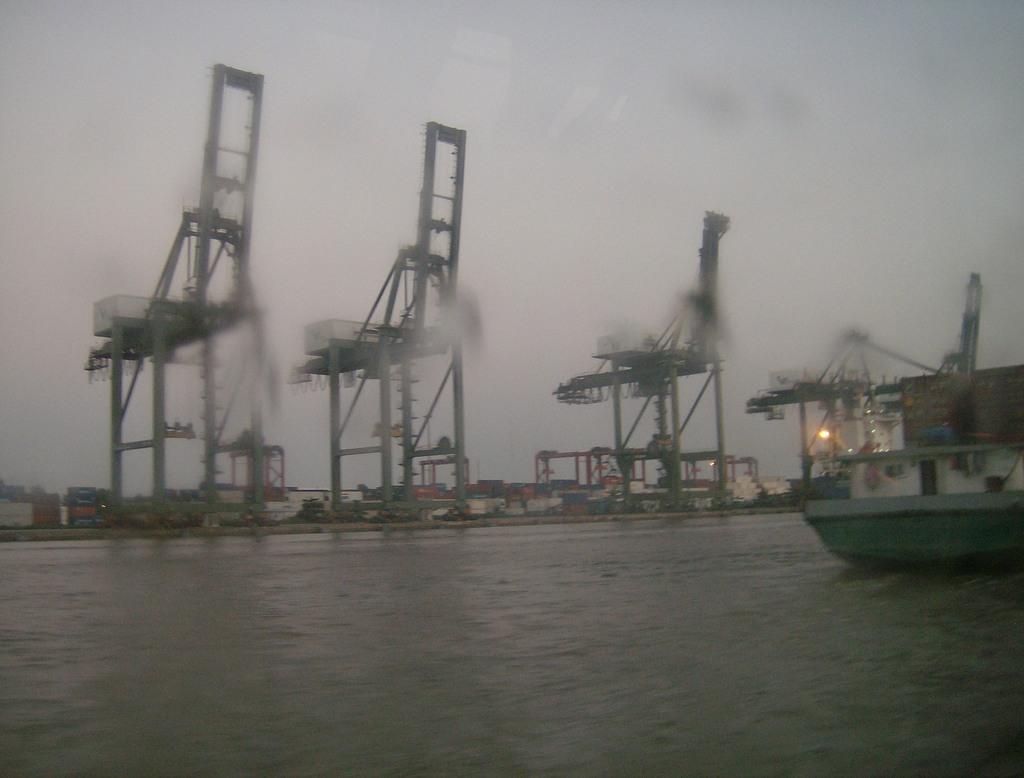Could you give a brief overview of what you see in this image? In this image there is a boat in the water. In the background of the image there are machines, lights and a few other objects. On the right side of the image there is a wall. At the top of the image there is sky. 